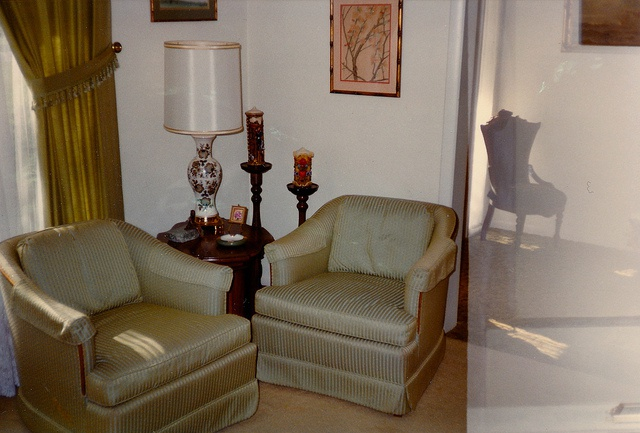Describe the objects in this image and their specific colors. I can see couch in black, olive, and gray tones, chair in black, olive, and gray tones, couch in black, gray, olive, and maroon tones, chair in black, gray, olive, and maroon tones, and chair in black and gray tones in this image. 